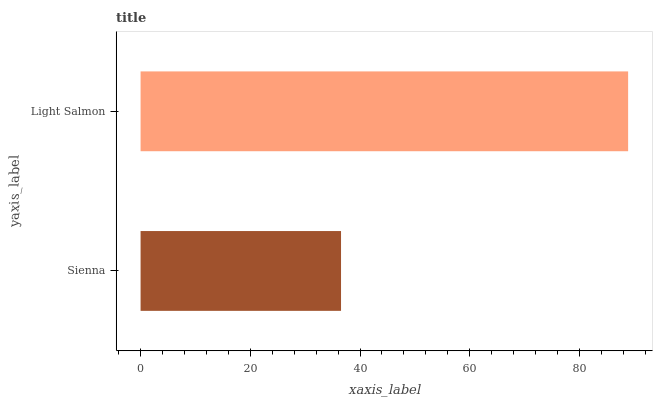Is Sienna the minimum?
Answer yes or no. Yes. Is Light Salmon the maximum?
Answer yes or no. Yes. Is Light Salmon the minimum?
Answer yes or no. No. Is Light Salmon greater than Sienna?
Answer yes or no. Yes. Is Sienna less than Light Salmon?
Answer yes or no. Yes. Is Sienna greater than Light Salmon?
Answer yes or no. No. Is Light Salmon less than Sienna?
Answer yes or no. No. Is Light Salmon the high median?
Answer yes or no. Yes. Is Sienna the low median?
Answer yes or no. Yes. Is Sienna the high median?
Answer yes or no. No. Is Light Salmon the low median?
Answer yes or no. No. 